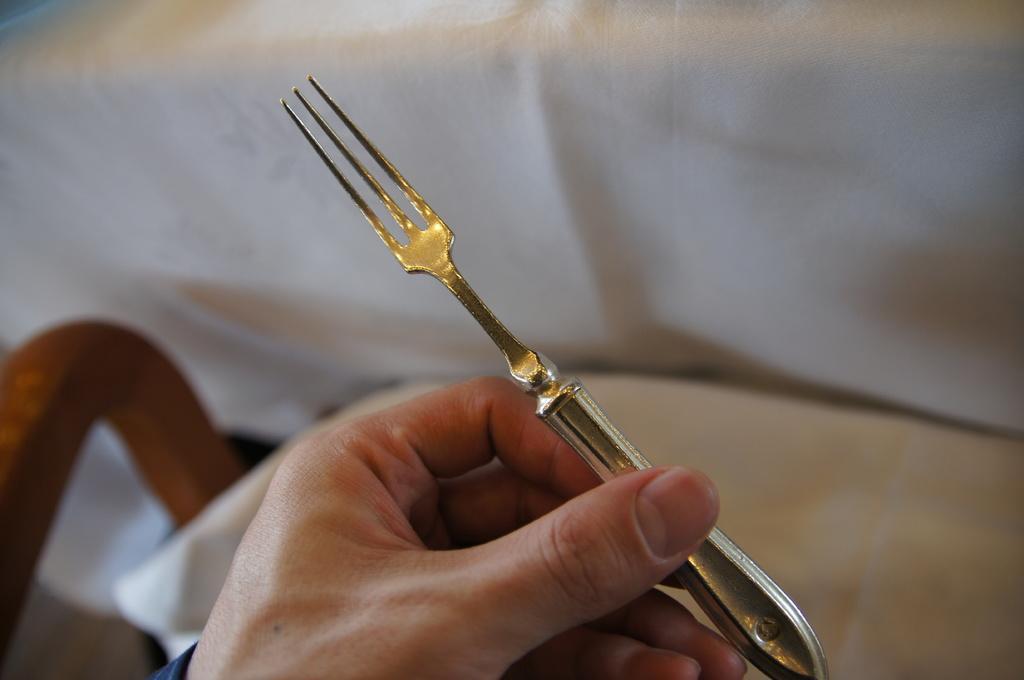Describe this image in one or two sentences. In this image in the front there is a person holding a fork in his hand. In the background there is a cloth which is white in colour and on the left side there is an object which is brown in colour. 